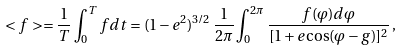Convert formula to latex. <formula><loc_0><loc_0><loc_500><loc_500>< f > = \frac { 1 } { T } \int ^ { T } _ { 0 } f d t = ( 1 - e ^ { 2 } ) ^ { 3 / 2 } \, \frac { 1 } { 2 \pi } \int ^ { 2 \pi } _ { 0 } \frac { f ( \varphi ) d \varphi } { [ 1 + e \cos ( \varphi - g ) ] ^ { 2 } } \, ,</formula> 